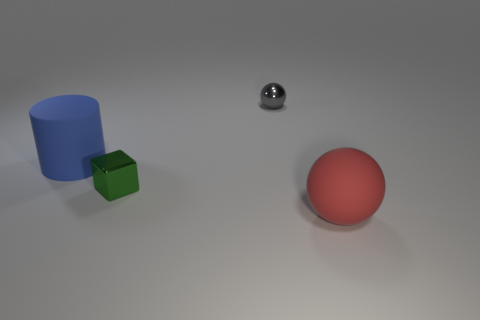What textures are present on the objects in this image? The objects in the image display a matte texture for both the blue cylinder and the green cube, while the red sphere and the small silver sphere present a glossy, reflective surface. 